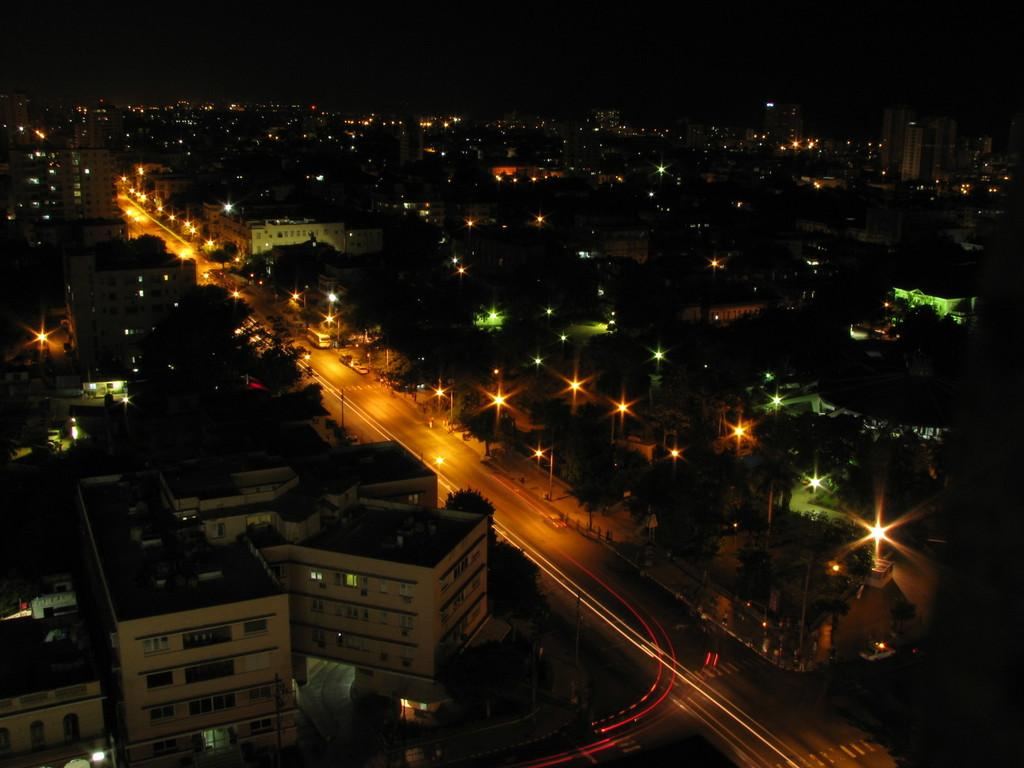What type of structures are visible in the image? There is a group of buildings in the image. What features can be seen on the buildings? The buildings have windows. What other objects can be seen in the image besides the buildings? There are trees, light poles, and a pathway in the image. What is visible in the background of the image? The sky is visible in the background of the image. Can you see any teeth on the buildings in the image? There are no teeth present on the buildings in the image. Is there a kitty playing with a stocking in the image? There is no kitty or stocking present in the image. 